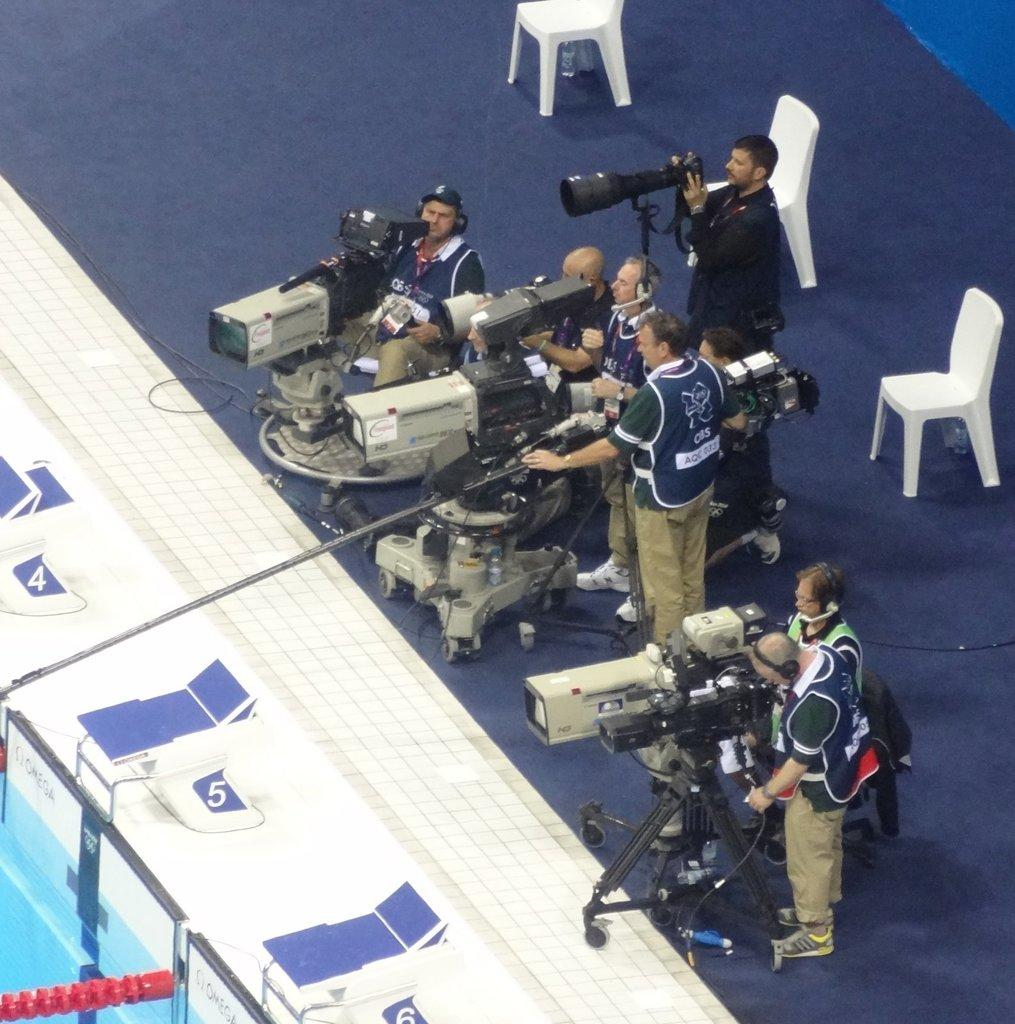What are the people in the image holding? The people in the image are holding cameras. What can be seen in the background of the image? There are chairs in the background of the image. What color is the orange that the people are smashing in the image? There is no orange or smashing activity present in the image. 